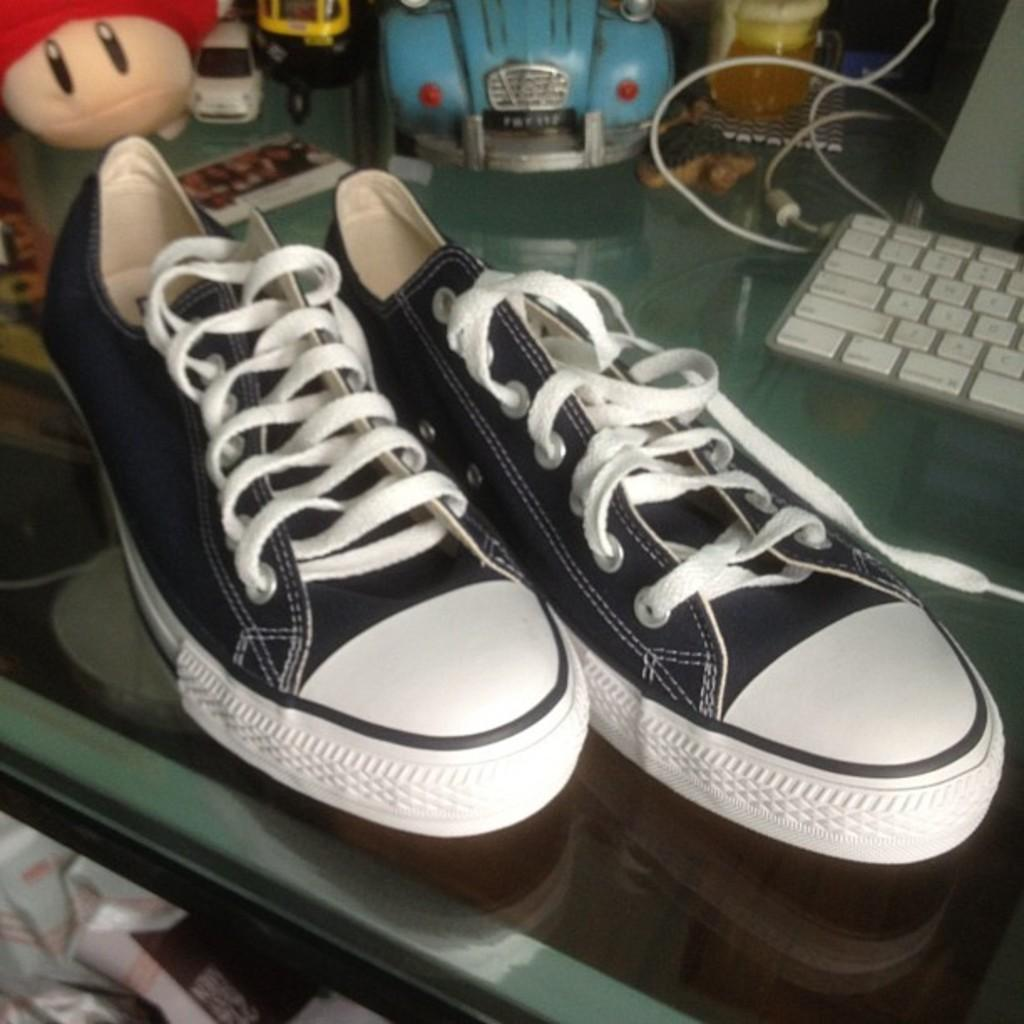What is the main object in the image? There is a table in the image. What items are placed on the table? There are cars, a doll, shoes, a keyboard, and a screen on the table. Can you describe the cars on the table? The cars are small toy cars. What might the keyboard and screen be used for? The keyboard and screen could be used for typing and displaying information, respectively. What type of cream is being used to teach the doll how to react in the image? There is no cream, teaching, or reaction involving the doll in the image. 